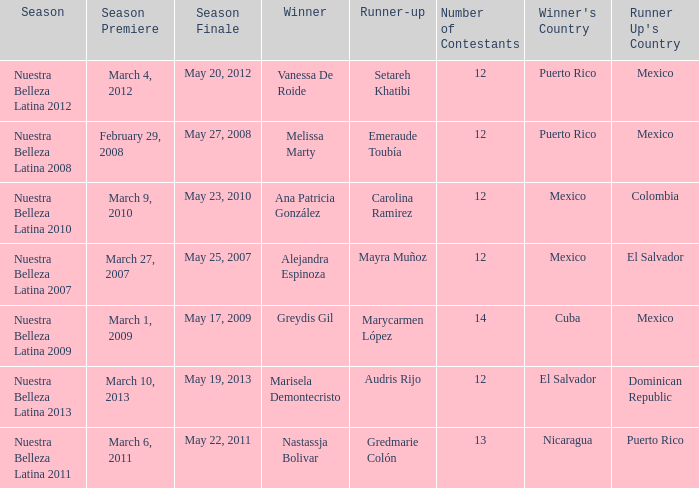How many contestants were there in a season where alejandra espinoza won? 1.0. Write the full table. {'header': ['Season', 'Season Premiere', 'Season Finale', 'Winner', 'Runner-up', 'Number of Contestants', "Winner's Country", "Runner Up's Country"], 'rows': [['Nuestra Belleza Latina 2012', 'March 4, 2012', 'May 20, 2012', 'Vanessa De Roide', 'Setareh Khatibi', '12', 'Puerto Rico', 'Mexico'], ['Nuestra Belleza Latina 2008', 'February 29, 2008', 'May 27, 2008', 'Melissa Marty', 'Emeraude Toubía', '12', 'Puerto Rico', 'Mexico'], ['Nuestra Belleza Latina 2010', 'March 9, 2010', 'May 23, 2010', 'Ana Patricia González', 'Carolina Ramirez', '12', 'Mexico', 'Colombia'], ['Nuestra Belleza Latina 2007', 'March 27, 2007', 'May 25, 2007', 'Alejandra Espinoza', 'Mayra Muñoz', '12', 'Mexico', 'El Salvador'], ['Nuestra Belleza Latina 2009', 'March 1, 2009', 'May 17, 2009', 'Greydis Gil', 'Marycarmen López', '14', 'Cuba', 'Mexico'], ['Nuestra Belleza Latina 2013', 'March 10, 2013', 'May 19, 2013', 'Marisela Demontecristo', 'Audris Rijo', '12', 'El Salvador', 'Dominican Republic'], ['Nuestra Belleza Latina 2011', 'March 6, 2011', 'May 22, 2011', 'Nastassja Bolivar', 'Gredmarie Colón', '13', 'Nicaragua', 'Puerto Rico']]} 